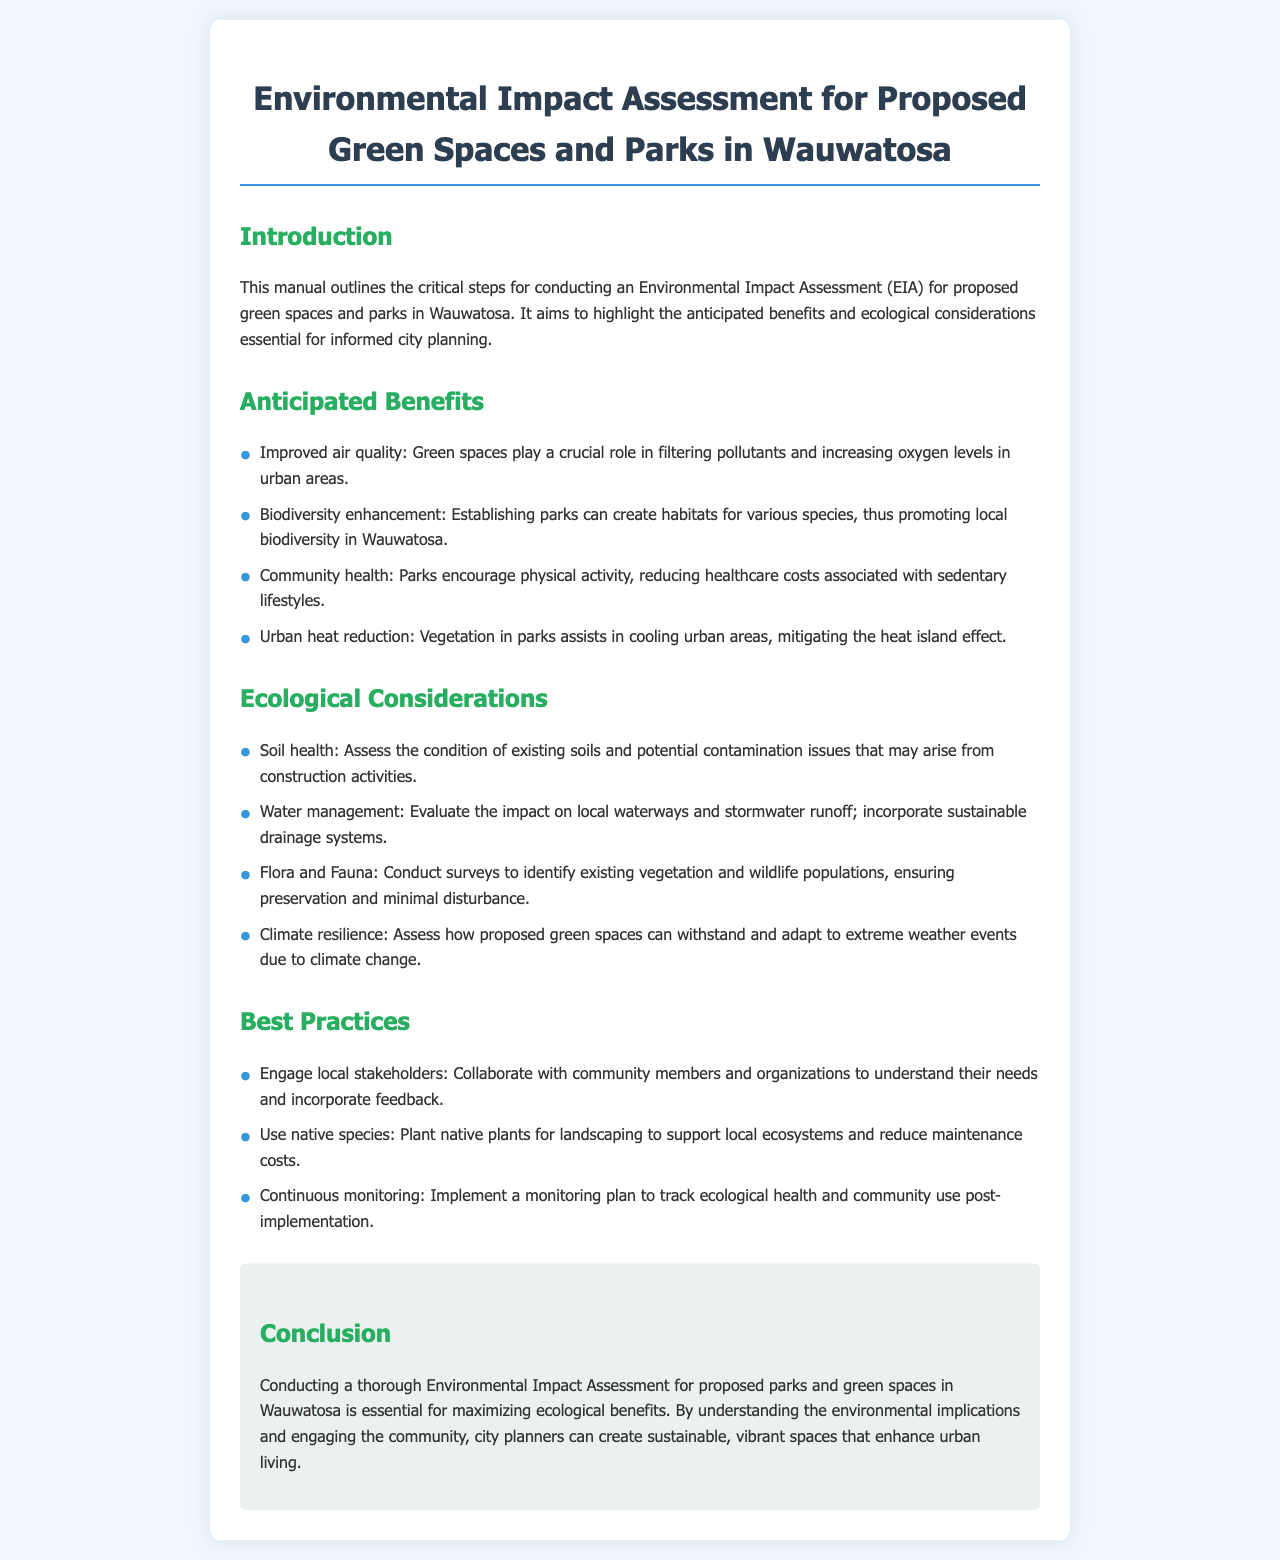What is the title of the document? The title of the document is provided in the header section, indicating its purpose and focus area.
Answer: Environmental Impact Assessment for Proposed Green Spaces and Parks in Wauwatosa What are two anticipated benefits of green spaces? The document lists the benefits in a bulleted format under the section titled "Anticipated Benefits."
Answer: Improved air quality, Biodiversity enhancement What is one of the ecological considerations mentioned? The document includes specific ecological considerations that need to be assessed under the "Ecological Considerations" section.
Answer: Soil health How many best practices are suggested? The number of best practices is derived from the bulleted list in the "Best Practices" section.
Answer: Three What is a suggested action regarding local stakeholders? The document emphasizes the importance of community involvement in the planning process.
Answer: Engage local stakeholders What do parks help to reduce concerning urban heat? The document mentions a specific environmental issue that parks can mitigate.
Answer: Urban heat island effect What is mentioned as a method to support local ecosystems? The document suggests using native plants as part of the landscaping approach.
Answer: Use native species What should a monitoring plan track post-implementation? The document refers to elements that should be monitored after the establishment of parks and green spaces.
Answer: Ecological health and community use What does the conclusion emphasize as essential for maximizing ecological benefits? The conclusion highlights a crucial step in the planning process necessary for maximizing positive outcomes.
Answer: Conducting a thorough Environmental Impact Assessment 